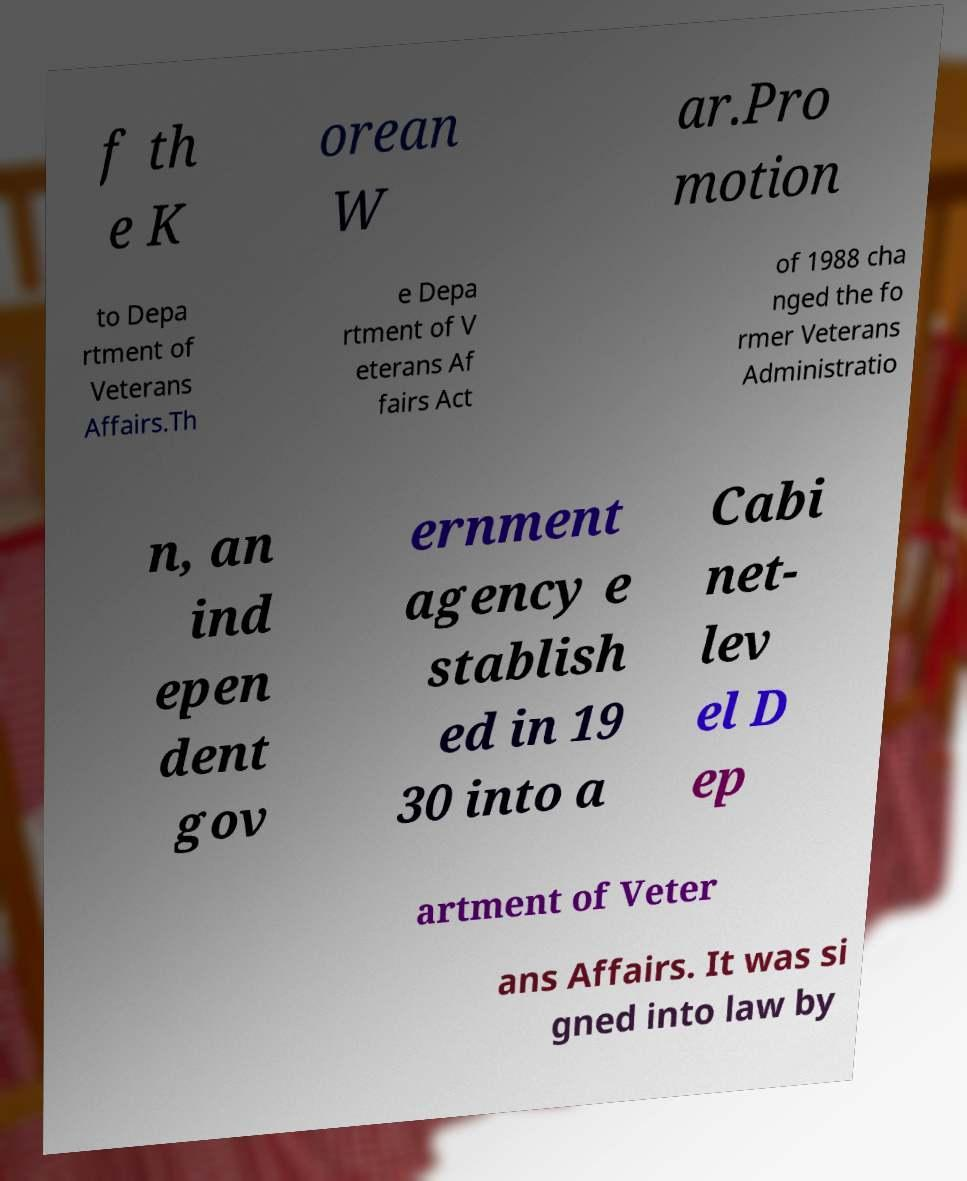Could you assist in decoding the text presented in this image and type it out clearly? f th e K orean W ar.Pro motion to Depa rtment of Veterans Affairs.Th e Depa rtment of V eterans Af fairs Act of 1988 cha nged the fo rmer Veterans Administratio n, an ind epen dent gov ernment agency e stablish ed in 19 30 into a Cabi net- lev el D ep artment of Veter ans Affairs. It was si gned into law by 